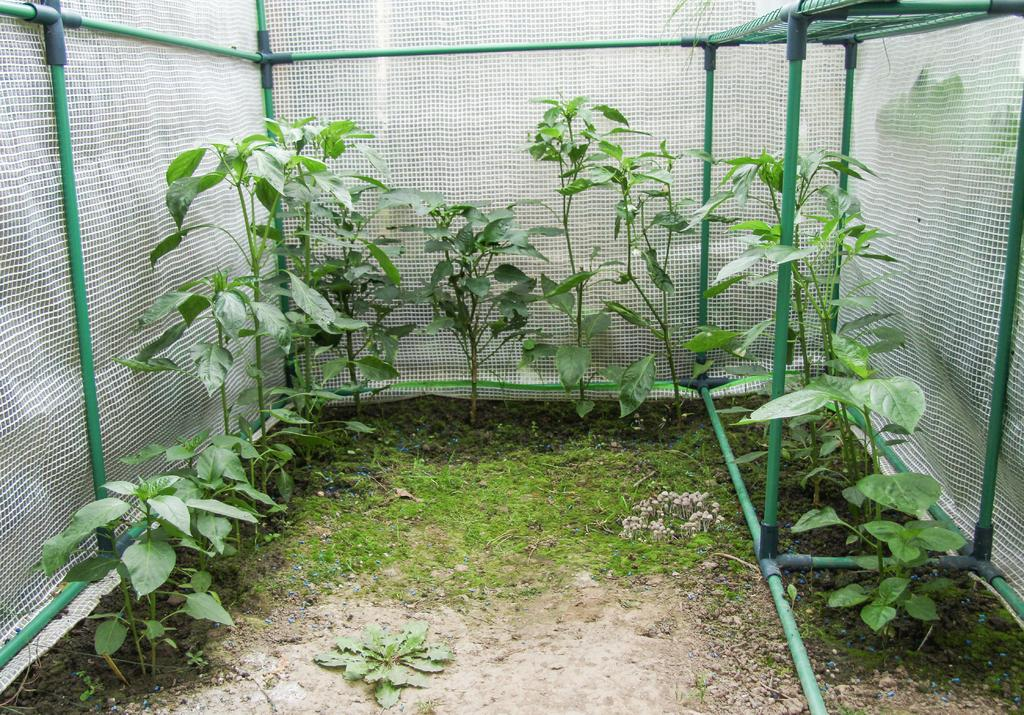What type of living organisms can be seen in the image? Plants can be seen in the image. What color are the rods visible in the image? The rods in the image are green. What can be seen in the background of the image? There is a net visible in the background of the image. What type of road can be seen in the image? There is no road present in the image. 